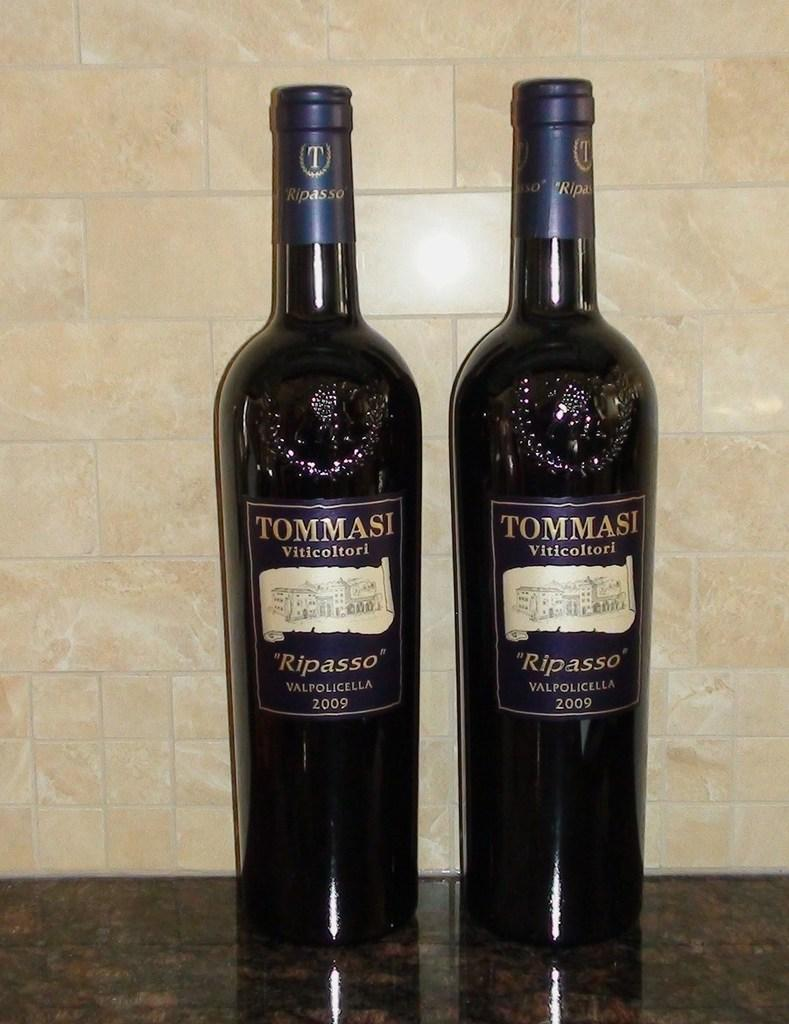<image>
Describe the image concisely. Tommasi Viticoltori ripasso valpolicella wine from 2009 on a counter 